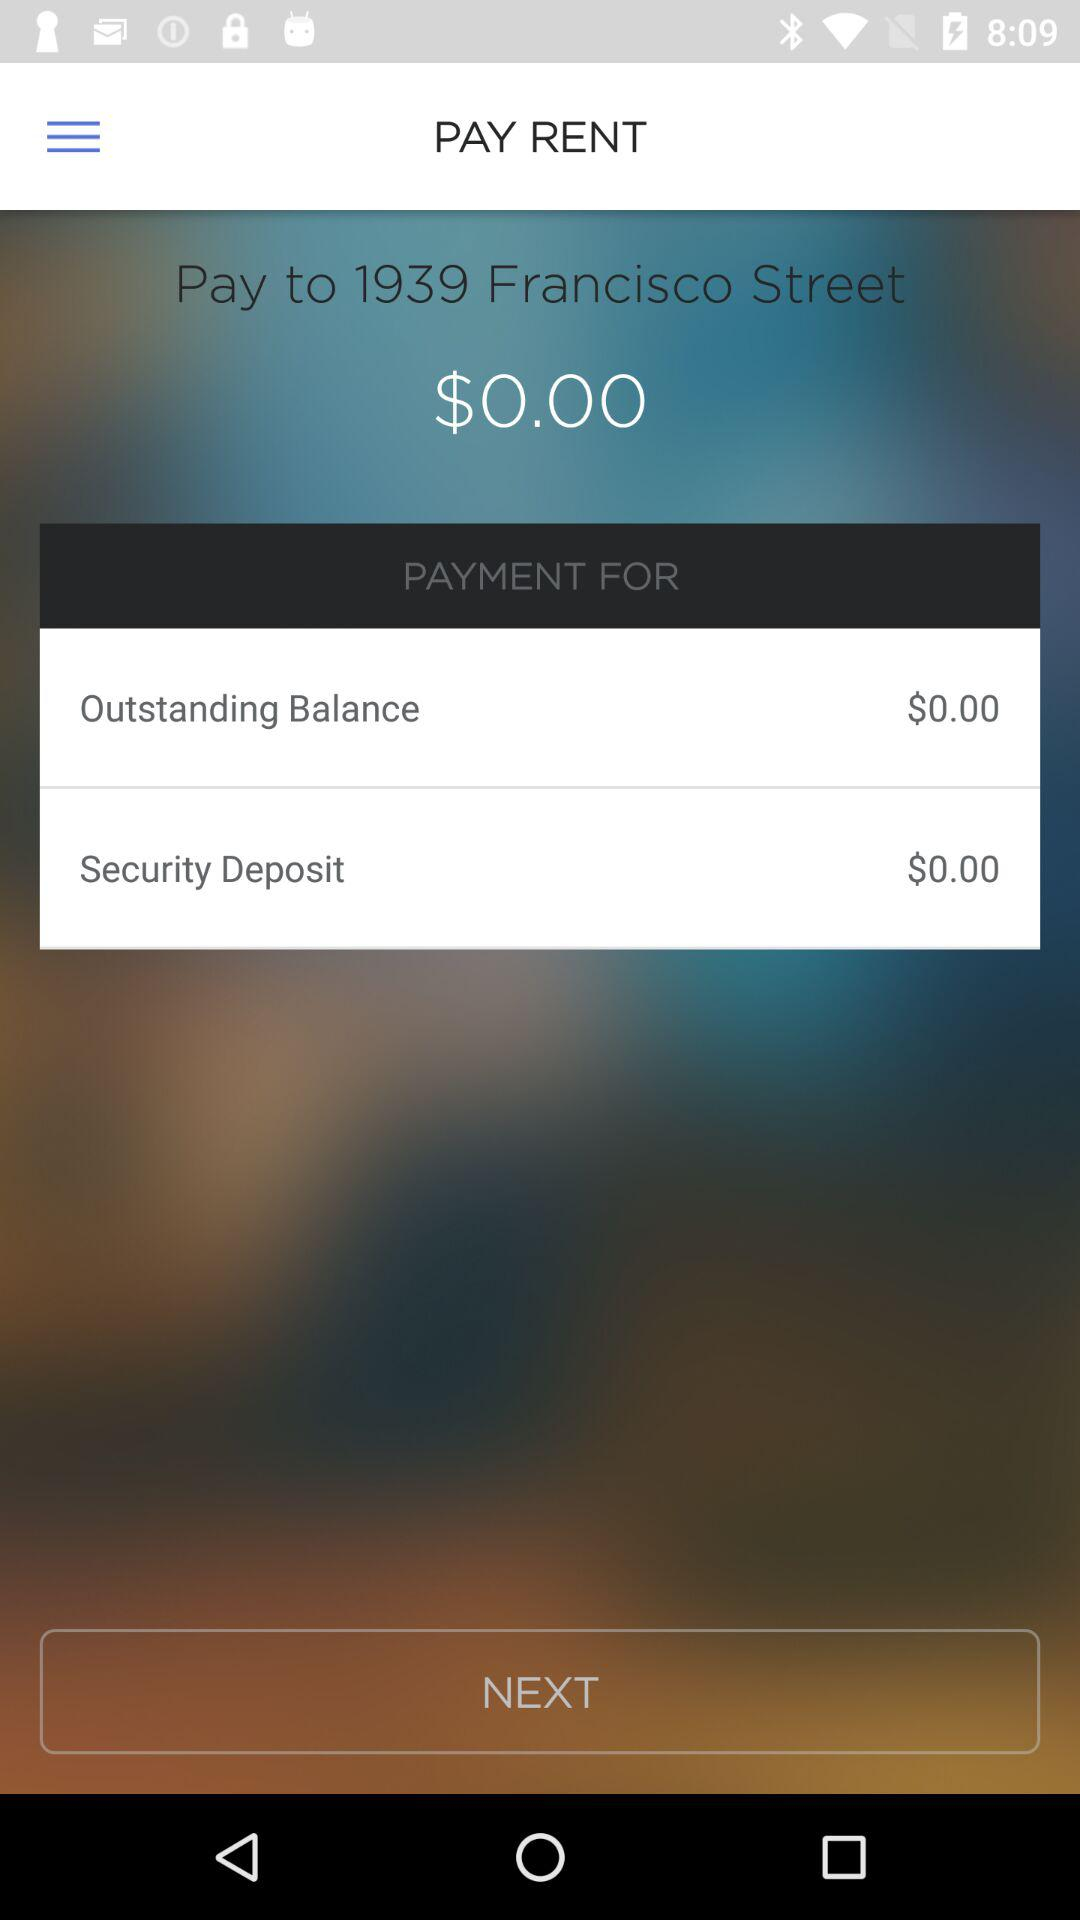How much is the security deposit?
Answer the question using a single word or phrase. $0.00 